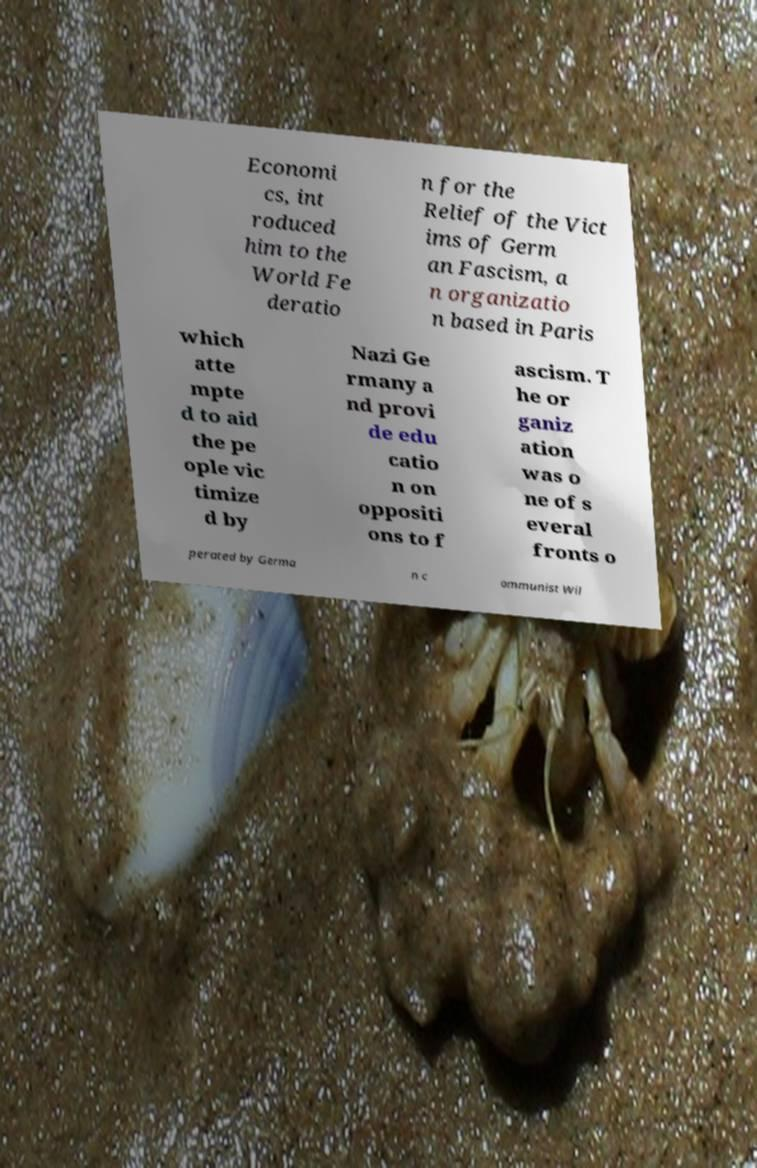Please read and relay the text visible in this image. What does it say? Economi cs, int roduced him to the World Fe deratio n for the Relief of the Vict ims of Germ an Fascism, a n organizatio n based in Paris which atte mpte d to aid the pe ople vic timize d by Nazi Ge rmany a nd provi de edu catio n on oppositi ons to f ascism. T he or ganiz ation was o ne of s everal fronts o perated by Germa n c ommunist Wil 